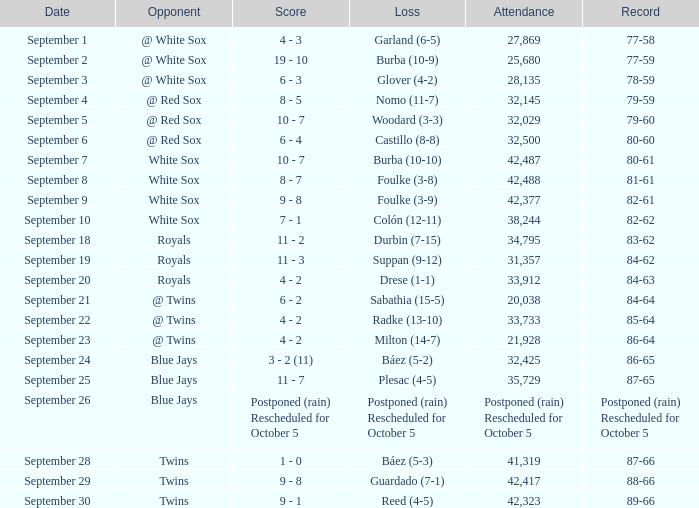What is the game's record with 28,135 individuals present? 78-59. 